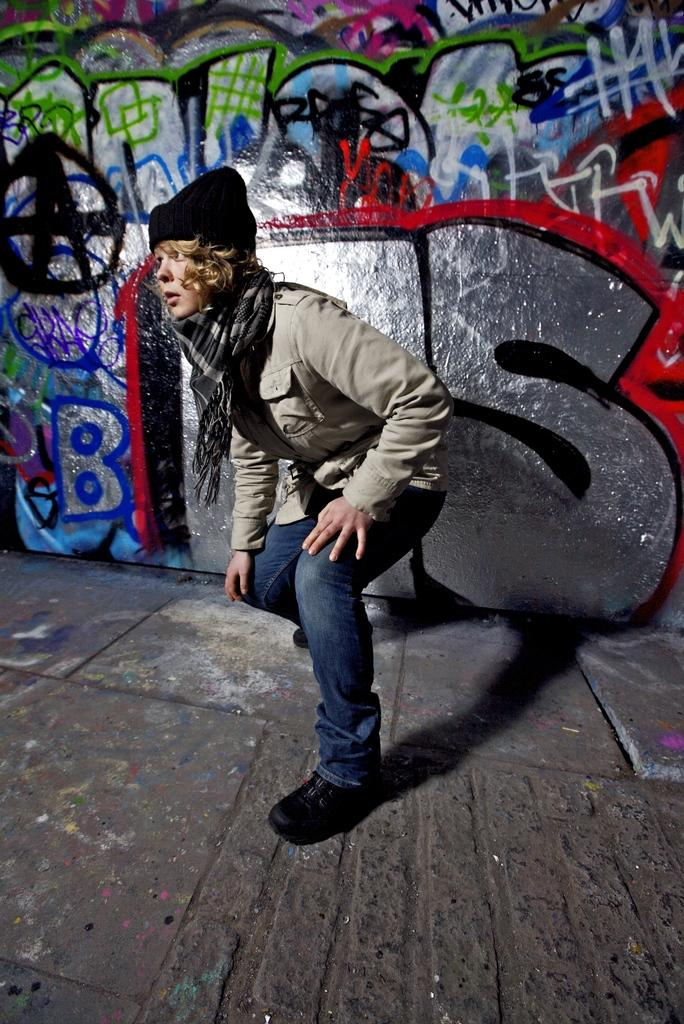Who or what is present in the image? There is a person in the image. What is the person's position in the image? The person is on the ground. What is the person wearing in the image? The person is wearing a stole. What can be seen in the background of the image? There is a graffiti wall in the background of the image. How many pigs are visible in the image? There are no pigs present in the image. What is the chance of winning a prize in the image? There is no indication of a prize or a chance to win in the image. 